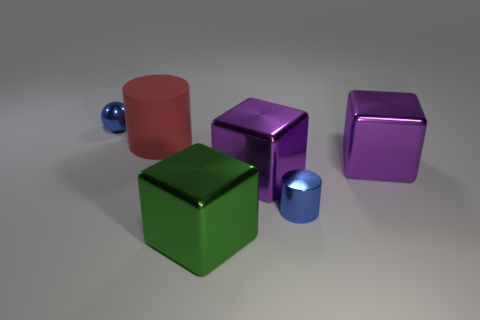Add 4 shiny cubes. How many objects exist? 10 Subtract all cylinders. How many objects are left? 4 Subtract all green shiny cubes. Subtract all tiny blue shiny objects. How many objects are left? 3 Add 6 big matte cylinders. How many big matte cylinders are left? 7 Add 1 metallic cubes. How many metallic cubes exist? 4 Subtract 0 purple balls. How many objects are left? 6 